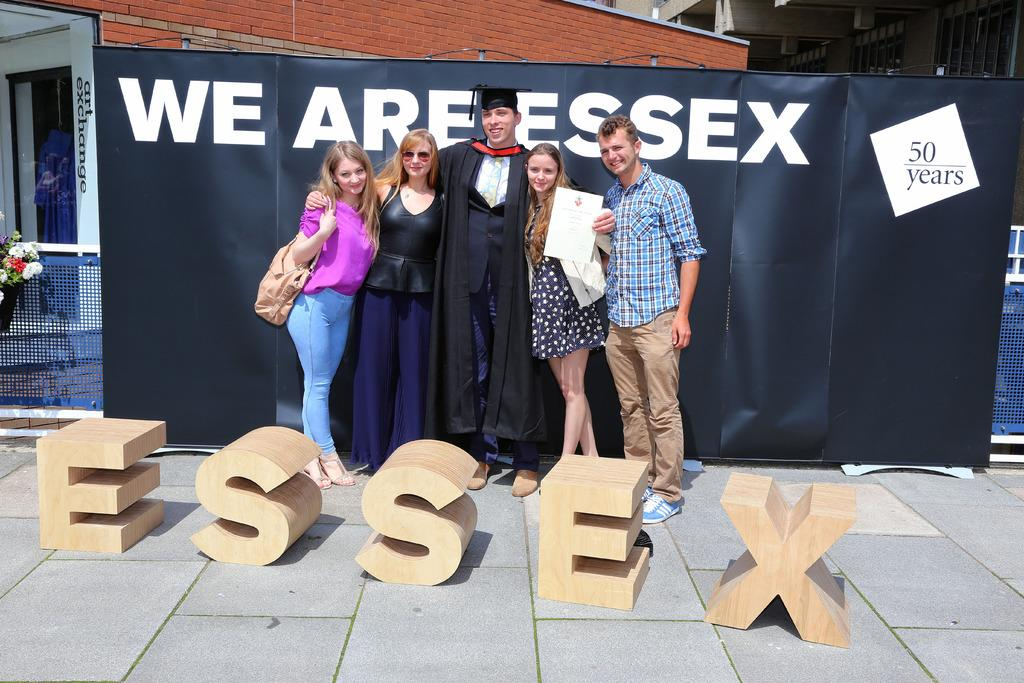How many people are in the image? There is a group of people in the image. What are the people doing in the image? The people are standing and smiling. What are the people holding in their hands? The people are holding a certificate in their hands. What can be seen in the background of the image? There is a building in the background of the image. What object is present that is related to sports or games? There is a net in the image. What type of toothpaste is being used by the people in the image? There is no toothpaste present in the image. How many ducks are visible in the image? There are no ducks visible in the image. 